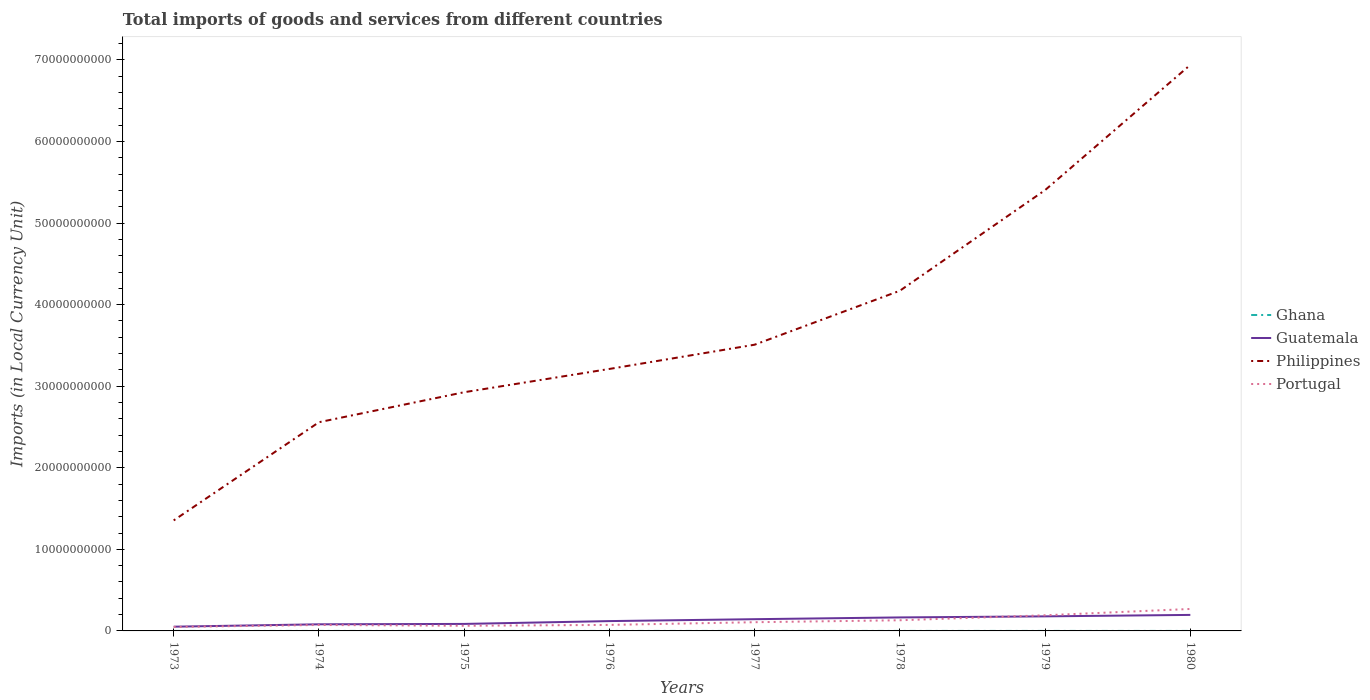Across all years, what is the maximum Amount of goods and services imports in Portugal?
Provide a short and direct response. 4.85e+08. What is the total Amount of goods and services imports in Portugal in the graph?
Offer a terse response. -3.30e+08. What is the difference between the highest and the second highest Amount of goods and services imports in Guatemala?
Ensure brevity in your answer.  1.44e+09. Are the values on the major ticks of Y-axis written in scientific E-notation?
Offer a terse response. No. Does the graph contain grids?
Make the answer very short. No. How many legend labels are there?
Ensure brevity in your answer.  4. How are the legend labels stacked?
Make the answer very short. Vertical. What is the title of the graph?
Provide a short and direct response. Total imports of goods and services from different countries. What is the label or title of the Y-axis?
Your answer should be very brief. Imports (in Local Currency Unit). What is the Imports (in Local Currency Unit) in Ghana in 1973?
Offer a terse response. 5.74e+04. What is the Imports (in Local Currency Unit) of Guatemala in 1973?
Your response must be concise. 5.19e+08. What is the Imports (in Local Currency Unit) in Philippines in 1973?
Offer a very short reply. 1.35e+1. What is the Imports (in Local Currency Unit) in Portugal in 1973?
Ensure brevity in your answer.  4.85e+08. What is the Imports (in Local Currency Unit) of Ghana in 1974?
Keep it short and to the point. 1.02e+05. What is the Imports (in Local Currency Unit) in Guatemala in 1974?
Provide a succinct answer. 8.11e+08. What is the Imports (in Local Currency Unit) of Philippines in 1974?
Keep it short and to the point. 2.56e+1. What is the Imports (in Local Currency Unit) of Portugal in 1974?
Offer a very short reply. 7.30e+08. What is the Imports (in Local Currency Unit) in Ghana in 1975?
Provide a succinct answer. 9.74e+04. What is the Imports (in Local Currency Unit) of Guatemala in 1975?
Your answer should be very brief. 8.58e+08. What is the Imports (in Local Currency Unit) in Philippines in 1975?
Your answer should be compact. 2.93e+1. What is the Imports (in Local Currency Unit) in Portugal in 1975?
Give a very brief answer. 6.30e+08. What is the Imports (in Local Currency Unit) in Ghana in 1976?
Provide a succinct answer. 1.05e+05. What is the Imports (in Local Currency Unit) of Guatemala in 1976?
Your answer should be compact. 1.20e+09. What is the Imports (in Local Currency Unit) of Philippines in 1976?
Ensure brevity in your answer.  3.21e+1. What is the Imports (in Local Currency Unit) of Portugal in 1976?
Keep it short and to the point. 7.38e+08. What is the Imports (in Local Currency Unit) in Ghana in 1977?
Your answer should be very brief. 1.29e+05. What is the Imports (in Local Currency Unit) of Guatemala in 1977?
Your answer should be very brief. 1.44e+09. What is the Imports (in Local Currency Unit) of Philippines in 1977?
Your response must be concise. 3.51e+1. What is the Imports (in Local Currency Unit) of Portugal in 1977?
Offer a terse response. 1.07e+09. What is the Imports (in Local Currency Unit) of Ghana in 1978?
Provide a succinct answer. 2.03e+05. What is the Imports (in Local Currency Unit) of Guatemala in 1978?
Ensure brevity in your answer.  1.66e+09. What is the Imports (in Local Currency Unit) of Philippines in 1978?
Your answer should be very brief. 4.17e+1. What is the Imports (in Local Currency Unit) in Portugal in 1978?
Provide a short and direct response. 1.31e+09. What is the Imports (in Local Currency Unit) of Ghana in 1979?
Keep it short and to the point. 3.15e+05. What is the Imports (in Local Currency Unit) in Guatemala in 1979?
Ensure brevity in your answer.  1.78e+09. What is the Imports (in Local Currency Unit) of Philippines in 1979?
Give a very brief answer. 5.40e+1. What is the Imports (in Local Currency Unit) of Portugal in 1979?
Provide a short and direct response. 1.92e+09. What is the Imports (in Local Currency Unit) in Ghana in 1980?
Make the answer very short. 3.92e+05. What is the Imports (in Local Currency Unit) of Guatemala in 1980?
Keep it short and to the point. 1.96e+09. What is the Imports (in Local Currency Unit) in Philippines in 1980?
Your answer should be very brief. 6.94e+1. What is the Imports (in Local Currency Unit) of Portugal in 1980?
Your response must be concise. 2.69e+09. Across all years, what is the maximum Imports (in Local Currency Unit) in Ghana?
Make the answer very short. 3.92e+05. Across all years, what is the maximum Imports (in Local Currency Unit) in Guatemala?
Offer a very short reply. 1.96e+09. Across all years, what is the maximum Imports (in Local Currency Unit) in Philippines?
Keep it short and to the point. 6.94e+1. Across all years, what is the maximum Imports (in Local Currency Unit) in Portugal?
Your answer should be compact. 2.69e+09. Across all years, what is the minimum Imports (in Local Currency Unit) in Ghana?
Offer a terse response. 5.74e+04. Across all years, what is the minimum Imports (in Local Currency Unit) of Guatemala?
Your answer should be compact. 5.19e+08. Across all years, what is the minimum Imports (in Local Currency Unit) of Philippines?
Provide a succinct answer. 1.35e+1. Across all years, what is the minimum Imports (in Local Currency Unit) of Portugal?
Provide a succinct answer. 4.85e+08. What is the total Imports (in Local Currency Unit) of Ghana in the graph?
Provide a short and direct response. 1.40e+06. What is the total Imports (in Local Currency Unit) in Guatemala in the graph?
Your answer should be compact. 1.02e+1. What is the total Imports (in Local Currency Unit) of Philippines in the graph?
Your answer should be very brief. 3.01e+11. What is the total Imports (in Local Currency Unit) in Portugal in the graph?
Your answer should be compact. 9.57e+09. What is the difference between the Imports (in Local Currency Unit) of Ghana in 1973 and that in 1974?
Your answer should be very brief. -4.42e+04. What is the difference between the Imports (in Local Currency Unit) in Guatemala in 1973 and that in 1974?
Your answer should be very brief. -2.92e+08. What is the difference between the Imports (in Local Currency Unit) of Philippines in 1973 and that in 1974?
Provide a succinct answer. -1.20e+1. What is the difference between the Imports (in Local Currency Unit) of Portugal in 1973 and that in 1974?
Offer a terse response. -2.44e+08. What is the difference between the Imports (in Local Currency Unit) in Guatemala in 1973 and that in 1975?
Provide a short and direct response. -3.39e+08. What is the difference between the Imports (in Local Currency Unit) of Philippines in 1973 and that in 1975?
Provide a short and direct response. -1.57e+1. What is the difference between the Imports (in Local Currency Unit) in Portugal in 1973 and that in 1975?
Give a very brief answer. -1.45e+08. What is the difference between the Imports (in Local Currency Unit) of Ghana in 1973 and that in 1976?
Your response must be concise. -4.73e+04. What is the difference between the Imports (in Local Currency Unit) of Guatemala in 1973 and that in 1976?
Provide a succinct answer. -6.85e+08. What is the difference between the Imports (in Local Currency Unit) of Philippines in 1973 and that in 1976?
Your answer should be compact. -1.86e+1. What is the difference between the Imports (in Local Currency Unit) in Portugal in 1973 and that in 1976?
Make the answer very short. -2.52e+08. What is the difference between the Imports (in Local Currency Unit) in Ghana in 1973 and that in 1977?
Offer a terse response. -7.15e+04. What is the difference between the Imports (in Local Currency Unit) of Guatemala in 1973 and that in 1977?
Make the answer very short. -9.20e+08. What is the difference between the Imports (in Local Currency Unit) of Philippines in 1973 and that in 1977?
Your response must be concise. -2.15e+1. What is the difference between the Imports (in Local Currency Unit) of Portugal in 1973 and that in 1977?
Keep it short and to the point. -5.83e+08. What is the difference between the Imports (in Local Currency Unit) of Ghana in 1973 and that in 1978?
Give a very brief answer. -1.46e+05. What is the difference between the Imports (in Local Currency Unit) of Guatemala in 1973 and that in 1978?
Give a very brief answer. -1.14e+09. What is the difference between the Imports (in Local Currency Unit) in Philippines in 1973 and that in 1978?
Provide a short and direct response. -2.82e+1. What is the difference between the Imports (in Local Currency Unit) in Portugal in 1973 and that in 1978?
Provide a short and direct response. -8.21e+08. What is the difference between the Imports (in Local Currency Unit) in Ghana in 1973 and that in 1979?
Your answer should be very brief. -2.58e+05. What is the difference between the Imports (in Local Currency Unit) of Guatemala in 1973 and that in 1979?
Make the answer very short. -1.27e+09. What is the difference between the Imports (in Local Currency Unit) of Philippines in 1973 and that in 1979?
Keep it short and to the point. -4.05e+1. What is the difference between the Imports (in Local Currency Unit) of Portugal in 1973 and that in 1979?
Give a very brief answer. -1.43e+09. What is the difference between the Imports (in Local Currency Unit) in Ghana in 1973 and that in 1980?
Provide a short and direct response. -3.35e+05. What is the difference between the Imports (in Local Currency Unit) in Guatemala in 1973 and that in 1980?
Your answer should be compact. -1.44e+09. What is the difference between the Imports (in Local Currency Unit) in Philippines in 1973 and that in 1980?
Your answer should be very brief. -5.58e+1. What is the difference between the Imports (in Local Currency Unit) in Portugal in 1973 and that in 1980?
Ensure brevity in your answer.  -2.21e+09. What is the difference between the Imports (in Local Currency Unit) of Ghana in 1974 and that in 1975?
Offer a very short reply. 4200. What is the difference between the Imports (in Local Currency Unit) of Guatemala in 1974 and that in 1975?
Provide a short and direct response. -4.66e+07. What is the difference between the Imports (in Local Currency Unit) in Philippines in 1974 and that in 1975?
Offer a terse response. -3.68e+09. What is the difference between the Imports (in Local Currency Unit) in Portugal in 1974 and that in 1975?
Make the answer very short. 9.95e+07. What is the difference between the Imports (in Local Currency Unit) of Ghana in 1974 and that in 1976?
Give a very brief answer. -3100. What is the difference between the Imports (in Local Currency Unit) of Guatemala in 1974 and that in 1976?
Ensure brevity in your answer.  -3.93e+08. What is the difference between the Imports (in Local Currency Unit) of Philippines in 1974 and that in 1976?
Keep it short and to the point. -6.53e+09. What is the difference between the Imports (in Local Currency Unit) of Portugal in 1974 and that in 1976?
Give a very brief answer. -7.79e+06. What is the difference between the Imports (in Local Currency Unit) in Ghana in 1974 and that in 1977?
Keep it short and to the point. -2.73e+04. What is the difference between the Imports (in Local Currency Unit) in Guatemala in 1974 and that in 1977?
Provide a short and direct response. -6.28e+08. What is the difference between the Imports (in Local Currency Unit) in Philippines in 1974 and that in 1977?
Give a very brief answer. -9.50e+09. What is the difference between the Imports (in Local Currency Unit) of Portugal in 1974 and that in 1977?
Your response must be concise. -3.38e+08. What is the difference between the Imports (in Local Currency Unit) of Ghana in 1974 and that in 1978?
Keep it short and to the point. -1.02e+05. What is the difference between the Imports (in Local Currency Unit) of Guatemala in 1974 and that in 1978?
Keep it short and to the point. -8.44e+08. What is the difference between the Imports (in Local Currency Unit) in Philippines in 1974 and that in 1978?
Give a very brief answer. -1.61e+1. What is the difference between the Imports (in Local Currency Unit) in Portugal in 1974 and that in 1978?
Provide a succinct answer. -5.76e+08. What is the difference between the Imports (in Local Currency Unit) in Ghana in 1974 and that in 1979?
Give a very brief answer. -2.13e+05. What is the difference between the Imports (in Local Currency Unit) of Guatemala in 1974 and that in 1979?
Ensure brevity in your answer.  -9.73e+08. What is the difference between the Imports (in Local Currency Unit) of Philippines in 1974 and that in 1979?
Ensure brevity in your answer.  -2.85e+1. What is the difference between the Imports (in Local Currency Unit) of Portugal in 1974 and that in 1979?
Ensure brevity in your answer.  -1.19e+09. What is the difference between the Imports (in Local Currency Unit) in Ghana in 1974 and that in 1980?
Offer a terse response. -2.91e+05. What is the difference between the Imports (in Local Currency Unit) in Guatemala in 1974 and that in 1980?
Keep it short and to the point. -1.15e+09. What is the difference between the Imports (in Local Currency Unit) in Philippines in 1974 and that in 1980?
Provide a succinct answer. -4.38e+1. What is the difference between the Imports (in Local Currency Unit) of Portugal in 1974 and that in 1980?
Offer a very short reply. -1.96e+09. What is the difference between the Imports (in Local Currency Unit) in Ghana in 1975 and that in 1976?
Your answer should be very brief. -7300. What is the difference between the Imports (in Local Currency Unit) of Guatemala in 1975 and that in 1976?
Provide a succinct answer. -3.46e+08. What is the difference between the Imports (in Local Currency Unit) of Philippines in 1975 and that in 1976?
Offer a very short reply. -2.85e+09. What is the difference between the Imports (in Local Currency Unit) of Portugal in 1975 and that in 1976?
Ensure brevity in your answer.  -1.07e+08. What is the difference between the Imports (in Local Currency Unit) of Ghana in 1975 and that in 1977?
Your response must be concise. -3.15e+04. What is the difference between the Imports (in Local Currency Unit) in Guatemala in 1975 and that in 1977?
Your response must be concise. -5.81e+08. What is the difference between the Imports (in Local Currency Unit) in Philippines in 1975 and that in 1977?
Your answer should be compact. -5.83e+09. What is the difference between the Imports (in Local Currency Unit) of Portugal in 1975 and that in 1977?
Keep it short and to the point. -4.38e+08. What is the difference between the Imports (in Local Currency Unit) of Ghana in 1975 and that in 1978?
Offer a terse response. -1.06e+05. What is the difference between the Imports (in Local Currency Unit) in Guatemala in 1975 and that in 1978?
Ensure brevity in your answer.  -7.97e+08. What is the difference between the Imports (in Local Currency Unit) in Philippines in 1975 and that in 1978?
Offer a terse response. -1.24e+1. What is the difference between the Imports (in Local Currency Unit) in Portugal in 1975 and that in 1978?
Ensure brevity in your answer.  -6.76e+08. What is the difference between the Imports (in Local Currency Unit) in Ghana in 1975 and that in 1979?
Provide a succinct answer. -2.18e+05. What is the difference between the Imports (in Local Currency Unit) in Guatemala in 1975 and that in 1979?
Offer a very short reply. -9.26e+08. What is the difference between the Imports (in Local Currency Unit) of Philippines in 1975 and that in 1979?
Your response must be concise. -2.48e+1. What is the difference between the Imports (in Local Currency Unit) of Portugal in 1975 and that in 1979?
Make the answer very short. -1.29e+09. What is the difference between the Imports (in Local Currency Unit) of Ghana in 1975 and that in 1980?
Your answer should be very brief. -2.95e+05. What is the difference between the Imports (in Local Currency Unit) of Guatemala in 1975 and that in 1980?
Provide a succinct answer. -1.11e+09. What is the difference between the Imports (in Local Currency Unit) of Philippines in 1975 and that in 1980?
Provide a short and direct response. -4.01e+1. What is the difference between the Imports (in Local Currency Unit) in Portugal in 1975 and that in 1980?
Your answer should be compact. -2.06e+09. What is the difference between the Imports (in Local Currency Unit) of Ghana in 1976 and that in 1977?
Provide a short and direct response. -2.42e+04. What is the difference between the Imports (in Local Currency Unit) of Guatemala in 1976 and that in 1977?
Offer a very short reply. -2.35e+08. What is the difference between the Imports (in Local Currency Unit) of Philippines in 1976 and that in 1977?
Give a very brief answer. -2.97e+09. What is the difference between the Imports (in Local Currency Unit) in Portugal in 1976 and that in 1977?
Your response must be concise. -3.30e+08. What is the difference between the Imports (in Local Currency Unit) in Ghana in 1976 and that in 1978?
Your answer should be very brief. -9.86e+04. What is the difference between the Imports (in Local Currency Unit) in Guatemala in 1976 and that in 1978?
Make the answer very short. -4.51e+08. What is the difference between the Imports (in Local Currency Unit) of Philippines in 1976 and that in 1978?
Give a very brief answer. -9.59e+09. What is the difference between the Imports (in Local Currency Unit) in Portugal in 1976 and that in 1978?
Your response must be concise. -5.69e+08. What is the difference between the Imports (in Local Currency Unit) in Ghana in 1976 and that in 1979?
Offer a terse response. -2.10e+05. What is the difference between the Imports (in Local Currency Unit) in Guatemala in 1976 and that in 1979?
Keep it short and to the point. -5.80e+08. What is the difference between the Imports (in Local Currency Unit) of Philippines in 1976 and that in 1979?
Your answer should be compact. -2.19e+1. What is the difference between the Imports (in Local Currency Unit) of Portugal in 1976 and that in 1979?
Ensure brevity in your answer.  -1.18e+09. What is the difference between the Imports (in Local Currency Unit) of Ghana in 1976 and that in 1980?
Offer a terse response. -2.88e+05. What is the difference between the Imports (in Local Currency Unit) of Guatemala in 1976 and that in 1980?
Provide a succinct answer. -7.59e+08. What is the difference between the Imports (in Local Currency Unit) of Philippines in 1976 and that in 1980?
Provide a short and direct response. -3.73e+1. What is the difference between the Imports (in Local Currency Unit) in Portugal in 1976 and that in 1980?
Your answer should be compact. -1.96e+09. What is the difference between the Imports (in Local Currency Unit) in Ghana in 1977 and that in 1978?
Provide a short and direct response. -7.44e+04. What is the difference between the Imports (in Local Currency Unit) in Guatemala in 1977 and that in 1978?
Your response must be concise. -2.16e+08. What is the difference between the Imports (in Local Currency Unit) in Philippines in 1977 and that in 1978?
Make the answer very short. -6.62e+09. What is the difference between the Imports (in Local Currency Unit) of Portugal in 1977 and that in 1978?
Your response must be concise. -2.38e+08. What is the difference between the Imports (in Local Currency Unit) in Ghana in 1977 and that in 1979?
Give a very brief answer. -1.86e+05. What is the difference between the Imports (in Local Currency Unit) of Guatemala in 1977 and that in 1979?
Ensure brevity in your answer.  -3.45e+08. What is the difference between the Imports (in Local Currency Unit) of Philippines in 1977 and that in 1979?
Your answer should be compact. -1.90e+1. What is the difference between the Imports (in Local Currency Unit) of Portugal in 1977 and that in 1979?
Provide a succinct answer. -8.51e+08. What is the difference between the Imports (in Local Currency Unit) in Ghana in 1977 and that in 1980?
Make the answer very short. -2.63e+05. What is the difference between the Imports (in Local Currency Unit) of Guatemala in 1977 and that in 1980?
Keep it short and to the point. -5.24e+08. What is the difference between the Imports (in Local Currency Unit) in Philippines in 1977 and that in 1980?
Your answer should be compact. -3.43e+1. What is the difference between the Imports (in Local Currency Unit) of Portugal in 1977 and that in 1980?
Your response must be concise. -1.62e+09. What is the difference between the Imports (in Local Currency Unit) of Ghana in 1978 and that in 1979?
Keep it short and to the point. -1.12e+05. What is the difference between the Imports (in Local Currency Unit) of Guatemala in 1978 and that in 1979?
Ensure brevity in your answer.  -1.29e+08. What is the difference between the Imports (in Local Currency Unit) in Philippines in 1978 and that in 1979?
Provide a short and direct response. -1.23e+1. What is the difference between the Imports (in Local Currency Unit) in Portugal in 1978 and that in 1979?
Provide a succinct answer. -6.13e+08. What is the difference between the Imports (in Local Currency Unit) of Ghana in 1978 and that in 1980?
Offer a terse response. -1.89e+05. What is the difference between the Imports (in Local Currency Unit) in Guatemala in 1978 and that in 1980?
Make the answer very short. -3.08e+08. What is the difference between the Imports (in Local Currency Unit) in Philippines in 1978 and that in 1980?
Your answer should be very brief. -2.77e+1. What is the difference between the Imports (in Local Currency Unit) in Portugal in 1978 and that in 1980?
Make the answer very short. -1.39e+09. What is the difference between the Imports (in Local Currency Unit) in Ghana in 1979 and that in 1980?
Keep it short and to the point. -7.73e+04. What is the difference between the Imports (in Local Currency Unit) in Guatemala in 1979 and that in 1980?
Keep it short and to the point. -1.79e+08. What is the difference between the Imports (in Local Currency Unit) in Philippines in 1979 and that in 1980?
Keep it short and to the point. -1.54e+1. What is the difference between the Imports (in Local Currency Unit) in Portugal in 1979 and that in 1980?
Offer a terse response. -7.74e+08. What is the difference between the Imports (in Local Currency Unit) of Ghana in 1973 and the Imports (in Local Currency Unit) of Guatemala in 1974?
Your answer should be compact. -8.11e+08. What is the difference between the Imports (in Local Currency Unit) of Ghana in 1973 and the Imports (in Local Currency Unit) of Philippines in 1974?
Provide a short and direct response. -2.56e+1. What is the difference between the Imports (in Local Currency Unit) of Ghana in 1973 and the Imports (in Local Currency Unit) of Portugal in 1974?
Offer a very short reply. -7.30e+08. What is the difference between the Imports (in Local Currency Unit) of Guatemala in 1973 and the Imports (in Local Currency Unit) of Philippines in 1974?
Give a very brief answer. -2.51e+1. What is the difference between the Imports (in Local Currency Unit) in Guatemala in 1973 and the Imports (in Local Currency Unit) in Portugal in 1974?
Your answer should be compact. -2.11e+08. What is the difference between the Imports (in Local Currency Unit) of Philippines in 1973 and the Imports (in Local Currency Unit) of Portugal in 1974?
Keep it short and to the point. 1.28e+1. What is the difference between the Imports (in Local Currency Unit) in Ghana in 1973 and the Imports (in Local Currency Unit) in Guatemala in 1975?
Ensure brevity in your answer.  -8.58e+08. What is the difference between the Imports (in Local Currency Unit) of Ghana in 1973 and the Imports (in Local Currency Unit) of Philippines in 1975?
Offer a terse response. -2.93e+1. What is the difference between the Imports (in Local Currency Unit) in Ghana in 1973 and the Imports (in Local Currency Unit) in Portugal in 1975?
Offer a terse response. -6.30e+08. What is the difference between the Imports (in Local Currency Unit) of Guatemala in 1973 and the Imports (in Local Currency Unit) of Philippines in 1975?
Make the answer very short. -2.87e+1. What is the difference between the Imports (in Local Currency Unit) of Guatemala in 1973 and the Imports (in Local Currency Unit) of Portugal in 1975?
Give a very brief answer. -1.11e+08. What is the difference between the Imports (in Local Currency Unit) of Philippines in 1973 and the Imports (in Local Currency Unit) of Portugal in 1975?
Offer a very short reply. 1.29e+1. What is the difference between the Imports (in Local Currency Unit) of Ghana in 1973 and the Imports (in Local Currency Unit) of Guatemala in 1976?
Make the answer very short. -1.20e+09. What is the difference between the Imports (in Local Currency Unit) of Ghana in 1973 and the Imports (in Local Currency Unit) of Philippines in 1976?
Offer a terse response. -3.21e+1. What is the difference between the Imports (in Local Currency Unit) of Ghana in 1973 and the Imports (in Local Currency Unit) of Portugal in 1976?
Offer a very short reply. -7.38e+08. What is the difference between the Imports (in Local Currency Unit) of Guatemala in 1973 and the Imports (in Local Currency Unit) of Philippines in 1976?
Offer a very short reply. -3.16e+1. What is the difference between the Imports (in Local Currency Unit) of Guatemala in 1973 and the Imports (in Local Currency Unit) of Portugal in 1976?
Offer a very short reply. -2.18e+08. What is the difference between the Imports (in Local Currency Unit) of Philippines in 1973 and the Imports (in Local Currency Unit) of Portugal in 1976?
Provide a succinct answer. 1.28e+1. What is the difference between the Imports (in Local Currency Unit) of Ghana in 1973 and the Imports (in Local Currency Unit) of Guatemala in 1977?
Your response must be concise. -1.44e+09. What is the difference between the Imports (in Local Currency Unit) in Ghana in 1973 and the Imports (in Local Currency Unit) in Philippines in 1977?
Your answer should be compact. -3.51e+1. What is the difference between the Imports (in Local Currency Unit) of Ghana in 1973 and the Imports (in Local Currency Unit) of Portugal in 1977?
Make the answer very short. -1.07e+09. What is the difference between the Imports (in Local Currency Unit) in Guatemala in 1973 and the Imports (in Local Currency Unit) in Philippines in 1977?
Your response must be concise. -3.46e+1. What is the difference between the Imports (in Local Currency Unit) in Guatemala in 1973 and the Imports (in Local Currency Unit) in Portugal in 1977?
Make the answer very short. -5.49e+08. What is the difference between the Imports (in Local Currency Unit) of Philippines in 1973 and the Imports (in Local Currency Unit) of Portugal in 1977?
Offer a terse response. 1.25e+1. What is the difference between the Imports (in Local Currency Unit) in Ghana in 1973 and the Imports (in Local Currency Unit) in Guatemala in 1978?
Your answer should be compact. -1.65e+09. What is the difference between the Imports (in Local Currency Unit) of Ghana in 1973 and the Imports (in Local Currency Unit) of Philippines in 1978?
Your answer should be compact. -4.17e+1. What is the difference between the Imports (in Local Currency Unit) of Ghana in 1973 and the Imports (in Local Currency Unit) of Portugal in 1978?
Your answer should be very brief. -1.31e+09. What is the difference between the Imports (in Local Currency Unit) in Guatemala in 1973 and the Imports (in Local Currency Unit) in Philippines in 1978?
Provide a succinct answer. -4.12e+1. What is the difference between the Imports (in Local Currency Unit) in Guatemala in 1973 and the Imports (in Local Currency Unit) in Portugal in 1978?
Your answer should be compact. -7.87e+08. What is the difference between the Imports (in Local Currency Unit) of Philippines in 1973 and the Imports (in Local Currency Unit) of Portugal in 1978?
Make the answer very short. 1.22e+1. What is the difference between the Imports (in Local Currency Unit) in Ghana in 1973 and the Imports (in Local Currency Unit) in Guatemala in 1979?
Give a very brief answer. -1.78e+09. What is the difference between the Imports (in Local Currency Unit) of Ghana in 1973 and the Imports (in Local Currency Unit) of Philippines in 1979?
Your response must be concise. -5.40e+1. What is the difference between the Imports (in Local Currency Unit) of Ghana in 1973 and the Imports (in Local Currency Unit) of Portugal in 1979?
Ensure brevity in your answer.  -1.92e+09. What is the difference between the Imports (in Local Currency Unit) of Guatemala in 1973 and the Imports (in Local Currency Unit) of Philippines in 1979?
Your answer should be very brief. -5.35e+1. What is the difference between the Imports (in Local Currency Unit) in Guatemala in 1973 and the Imports (in Local Currency Unit) in Portugal in 1979?
Provide a succinct answer. -1.40e+09. What is the difference between the Imports (in Local Currency Unit) of Philippines in 1973 and the Imports (in Local Currency Unit) of Portugal in 1979?
Your response must be concise. 1.16e+1. What is the difference between the Imports (in Local Currency Unit) of Ghana in 1973 and the Imports (in Local Currency Unit) of Guatemala in 1980?
Offer a terse response. -1.96e+09. What is the difference between the Imports (in Local Currency Unit) in Ghana in 1973 and the Imports (in Local Currency Unit) in Philippines in 1980?
Keep it short and to the point. -6.94e+1. What is the difference between the Imports (in Local Currency Unit) of Ghana in 1973 and the Imports (in Local Currency Unit) of Portugal in 1980?
Your answer should be very brief. -2.69e+09. What is the difference between the Imports (in Local Currency Unit) of Guatemala in 1973 and the Imports (in Local Currency Unit) of Philippines in 1980?
Ensure brevity in your answer.  -6.89e+1. What is the difference between the Imports (in Local Currency Unit) of Guatemala in 1973 and the Imports (in Local Currency Unit) of Portugal in 1980?
Your response must be concise. -2.17e+09. What is the difference between the Imports (in Local Currency Unit) of Philippines in 1973 and the Imports (in Local Currency Unit) of Portugal in 1980?
Make the answer very short. 1.09e+1. What is the difference between the Imports (in Local Currency Unit) of Ghana in 1974 and the Imports (in Local Currency Unit) of Guatemala in 1975?
Offer a very short reply. -8.58e+08. What is the difference between the Imports (in Local Currency Unit) in Ghana in 1974 and the Imports (in Local Currency Unit) in Philippines in 1975?
Offer a terse response. -2.93e+1. What is the difference between the Imports (in Local Currency Unit) in Ghana in 1974 and the Imports (in Local Currency Unit) in Portugal in 1975?
Make the answer very short. -6.30e+08. What is the difference between the Imports (in Local Currency Unit) of Guatemala in 1974 and the Imports (in Local Currency Unit) of Philippines in 1975?
Offer a very short reply. -2.85e+1. What is the difference between the Imports (in Local Currency Unit) in Guatemala in 1974 and the Imports (in Local Currency Unit) in Portugal in 1975?
Keep it short and to the point. 1.81e+08. What is the difference between the Imports (in Local Currency Unit) in Philippines in 1974 and the Imports (in Local Currency Unit) in Portugal in 1975?
Your response must be concise. 2.50e+1. What is the difference between the Imports (in Local Currency Unit) of Ghana in 1974 and the Imports (in Local Currency Unit) of Guatemala in 1976?
Offer a very short reply. -1.20e+09. What is the difference between the Imports (in Local Currency Unit) of Ghana in 1974 and the Imports (in Local Currency Unit) of Philippines in 1976?
Your answer should be compact. -3.21e+1. What is the difference between the Imports (in Local Currency Unit) in Ghana in 1974 and the Imports (in Local Currency Unit) in Portugal in 1976?
Provide a short and direct response. -7.37e+08. What is the difference between the Imports (in Local Currency Unit) in Guatemala in 1974 and the Imports (in Local Currency Unit) in Philippines in 1976?
Provide a succinct answer. -3.13e+1. What is the difference between the Imports (in Local Currency Unit) in Guatemala in 1974 and the Imports (in Local Currency Unit) in Portugal in 1976?
Offer a terse response. 7.38e+07. What is the difference between the Imports (in Local Currency Unit) in Philippines in 1974 and the Imports (in Local Currency Unit) in Portugal in 1976?
Provide a short and direct response. 2.48e+1. What is the difference between the Imports (in Local Currency Unit) in Ghana in 1974 and the Imports (in Local Currency Unit) in Guatemala in 1977?
Your answer should be compact. -1.44e+09. What is the difference between the Imports (in Local Currency Unit) in Ghana in 1974 and the Imports (in Local Currency Unit) in Philippines in 1977?
Your answer should be compact. -3.51e+1. What is the difference between the Imports (in Local Currency Unit) in Ghana in 1974 and the Imports (in Local Currency Unit) in Portugal in 1977?
Provide a succinct answer. -1.07e+09. What is the difference between the Imports (in Local Currency Unit) in Guatemala in 1974 and the Imports (in Local Currency Unit) in Philippines in 1977?
Your answer should be compact. -3.43e+1. What is the difference between the Imports (in Local Currency Unit) of Guatemala in 1974 and the Imports (in Local Currency Unit) of Portugal in 1977?
Your answer should be compact. -2.57e+08. What is the difference between the Imports (in Local Currency Unit) of Philippines in 1974 and the Imports (in Local Currency Unit) of Portugal in 1977?
Provide a short and direct response. 2.45e+1. What is the difference between the Imports (in Local Currency Unit) of Ghana in 1974 and the Imports (in Local Currency Unit) of Guatemala in 1978?
Keep it short and to the point. -1.65e+09. What is the difference between the Imports (in Local Currency Unit) in Ghana in 1974 and the Imports (in Local Currency Unit) in Philippines in 1978?
Offer a very short reply. -4.17e+1. What is the difference between the Imports (in Local Currency Unit) of Ghana in 1974 and the Imports (in Local Currency Unit) of Portugal in 1978?
Your answer should be very brief. -1.31e+09. What is the difference between the Imports (in Local Currency Unit) in Guatemala in 1974 and the Imports (in Local Currency Unit) in Philippines in 1978?
Provide a short and direct response. -4.09e+1. What is the difference between the Imports (in Local Currency Unit) in Guatemala in 1974 and the Imports (in Local Currency Unit) in Portugal in 1978?
Ensure brevity in your answer.  -4.95e+08. What is the difference between the Imports (in Local Currency Unit) in Philippines in 1974 and the Imports (in Local Currency Unit) in Portugal in 1978?
Your response must be concise. 2.43e+1. What is the difference between the Imports (in Local Currency Unit) in Ghana in 1974 and the Imports (in Local Currency Unit) in Guatemala in 1979?
Your answer should be very brief. -1.78e+09. What is the difference between the Imports (in Local Currency Unit) in Ghana in 1974 and the Imports (in Local Currency Unit) in Philippines in 1979?
Your answer should be compact. -5.40e+1. What is the difference between the Imports (in Local Currency Unit) in Ghana in 1974 and the Imports (in Local Currency Unit) in Portugal in 1979?
Offer a terse response. -1.92e+09. What is the difference between the Imports (in Local Currency Unit) in Guatemala in 1974 and the Imports (in Local Currency Unit) in Philippines in 1979?
Make the answer very short. -5.32e+1. What is the difference between the Imports (in Local Currency Unit) in Guatemala in 1974 and the Imports (in Local Currency Unit) in Portugal in 1979?
Make the answer very short. -1.11e+09. What is the difference between the Imports (in Local Currency Unit) of Philippines in 1974 and the Imports (in Local Currency Unit) of Portugal in 1979?
Keep it short and to the point. 2.37e+1. What is the difference between the Imports (in Local Currency Unit) in Ghana in 1974 and the Imports (in Local Currency Unit) in Guatemala in 1980?
Your response must be concise. -1.96e+09. What is the difference between the Imports (in Local Currency Unit) in Ghana in 1974 and the Imports (in Local Currency Unit) in Philippines in 1980?
Make the answer very short. -6.94e+1. What is the difference between the Imports (in Local Currency Unit) in Ghana in 1974 and the Imports (in Local Currency Unit) in Portugal in 1980?
Your answer should be compact. -2.69e+09. What is the difference between the Imports (in Local Currency Unit) of Guatemala in 1974 and the Imports (in Local Currency Unit) of Philippines in 1980?
Keep it short and to the point. -6.86e+1. What is the difference between the Imports (in Local Currency Unit) of Guatemala in 1974 and the Imports (in Local Currency Unit) of Portugal in 1980?
Provide a short and direct response. -1.88e+09. What is the difference between the Imports (in Local Currency Unit) in Philippines in 1974 and the Imports (in Local Currency Unit) in Portugal in 1980?
Keep it short and to the point. 2.29e+1. What is the difference between the Imports (in Local Currency Unit) of Ghana in 1975 and the Imports (in Local Currency Unit) of Guatemala in 1976?
Your answer should be very brief. -1.20e+09. What is the difference between the Imports (in Local Currency Unit) in Ghana in 1975 and the Imports (in Local Currency Unit) in Philippines in 1976?
Provide a succinct answer. -3.21e+1. What is the difference between the Imports (in Local Currency Unit) of Ghana in 1975 and the Imports (in Local Currency Unit) of Portugal in 1976?
Your response must be concise. -7.37e+08. What is the difference between the Imports (in Local Currency Unit) in Guatemala in 1975 and the Imports (in Local Currency Unit) in Philippines in 1976?
Your response must be concise. -3.13e+1. What is the difference between the Imports (in Local Currency Unit) of Guatemala in 1975 and the Imports (in Local Currency Unit) of Portugal in 1976?
Offer a very short reply. 1.20e+08. What is the difference between the Imports (in Local Currency Unit) of Philippines in 1975 and the Imports (in Local Currency Unit) of Portugal in 1976?
Your answer should be very brief. 2.85e+1. What is the difference between the Imports (in Local Currency Unit) of Ghana in 1975 and the Imports (in Local Currency Unit) of Guatemala in 1977?
Keep it short and to the point. -1.44e+09. What is the difference between the Imports (in Local Currency Unit) in Ghana in 1975 and the Imports (in Local Currency Unit) in Philippines in 1977?
Offer a very short reply. -3.51e+1. What is the difference between the Imports (in Local Currency Unit) in Ghana in 1975 and the Imports (in Local Currency Unit) in Portugal in 1977?
Your answer should be very brief. -1.07e+09. What is the difference between the Imports (in Local Currency Unit) of Guatemala in 1975 and the Imports (in Local Currency Unit) of Philippines in 1977?
Provide a short and direct response. -3.42e+1. What is the difference between the Imports (in Local Currency Unit) of Guatemala in 1975 and the Imports (in Local Currency Unit) of Portugal in 1977?
Make the answer very short. -2.10e+08. What is the difference between the Imports (in Local Currency Unit) of Philippines in 1975 and the Imports (in Local Currency Unit) of Portugal in 1977?
Keep it short and to the point. 2.82e+1. What is the difference between the Imports (in Local Currency Unit) in Ghana in 1975 and the Imports (in Local Currency Unit) in Guatemala in 1978?
Ensure brevity in your answer.  -1.65e+09. What is the difference between the Imports (in Local Currency Unit) of Ghana in 1975 and the Imports (in Local Currency Unit) of Philippines in 1978?
Provide a succinct answer. -4.17e+1. What is the difference between the Imports (in Local Currency Unit) in Ghana in 1975 and the Imports (in Local Currency Unit) in Portugal in 1978?
Offer a terse response. -1.31e+09. What is the difference between the Imports (in Local Currency Unit) in Guatemala in 1975 and the Imports (in Local Currency Unit) in Philippines in 1978?
Your answer should be compact. -4.08e+1. What is the difference between the Imports (in Local Currency Unit) in Guatemala in 1975 and the Imports (in Local Currency Unit) in Portugal in 1978?
Give a very brief answer. -4.48e+08. What is the difference between the Imports (in Local Currency Unit) in Philippines in 1975 and the Imports (in Local Currency Unit) in Portugal in 1978?
Ensure brevity in your answer.  2.80e+1. What is the difference between the Imports (in Local Currency Unit) in Ghana in 1975 and the Imports (in Local Currency Unit) in Guatemala in 1979?
Provide a short and direct response. -1.78e+09. What is the difference between the Imports (in Local Currency Unit) in Ghana in 1975 and the Imports (in Local Currency Unit) in Philippines in 1979?
Offer a terse response. -5.40e+1. What is the difference between the Imports (in Local Currency Unit) in Ghana in 1975 and the Imports (in Local Currency Unit) in Portugal in 1979?
Provide a succinct answer. -1.92e+09. What is the difference between the Imports (in Local Currency Unit) of Guatemala in 1975 and the Imports (in Local Currency Unit) of Philippines in 1979?
Keep it short and to the point. -5.32e+1. What is the difference between the Imports (in Local Currency Unit) of Guatemala in 1975 and the Imports (in Local Currency Unit) of Portugal in 1979?
Offer a terse response. -1.06e+09. What is the difference between the Imports (in Local Currency Unit) of Philippines in 1975 and the Imports (in Local Currency Unit) of Portugal in 1979?
Give a very brief answer. 2.73e+1. What is the difference between the Imports (in Local Currency Unit) of Ghana in 1975 and the Imports (in Local Currency Unit) of Guatemala in 1980?
Offer a terse response. -1.96e+09. What is the difference between the Imports (in Local Currency Unit) of Ghana in 1975 and the Imports (in Local Currency Unit) of Philippines in 1980?
Your answer should be very brief. -6.94e+1. What is the difference between the Imports (in Local Currency Unit) in Ghana in 1975 and the Imports (in Local Currency Unit) in Portugal in 1980?
Offer a very short reply. -2.69e+09. What is the difference between the Imports (in Local Currency Unit) in Guatemala in 1975 and the Imports (in Local Currency Unit) in Philippines in 1980?
Keep it short and to the point. -6.85e+1. What is the difference between the Imports (in Local Currency Unit) of Guatemala in 1975 and the Imports (in Local Currency Unit) of Portugal in 1980?
Make the answer very short. -1.83e+09. What is the difference between the Imports (in Local Currency Unit) of Philippines in 1975 and the Imports (in Local Currency Unit) of Portugal in 1980?
Your response must be concise. 2.66e+1. What is the difference between the Imports (in Local Currency Unit) in Ghana in 1976 and the Imports (in Local Currency Unit) in Guatemala in 1977?
Offer a terse response. -1.44e+09. What is the difference between the Imports (in Local Currency Unit) in Ghana in 1976 and the Imports (in Local Currency Unit) in Philippines in 1977?
Make the answer very short. -3.51e+1. What is the difference between the Imports (in Local Currency Unit) of Ghana in 1976 and the Imports (in Local Currency Unit) of Portugal in 1977?
Your answer should be very brief. -1.07e+09. What is the difference between the Imports (in Local Currency Unit) of Guatemala in 1976 and the Imports (in Local Currency Unit) of Philippines in 1977?
Give a very brief answer. -3.39e+1. What is the difference between the Imports (in Local Currency Unit) in Guatemala in 1976 and the Imports (in Local Currency Unit) in Portugal in 1977?
Your answer should be compact. 1.36e+08. What is the difference between the Imports (in Local Currency Unit) of Philippines in 1976 and the Imports (in Local Currency Unit) of Portugal in 1977?
Offer a very short reply. 3.11e+1. What is the difference between the Imports (in Local Currency Unit) in Ghana in 1976 and the Imports (in Local Currency Unit) in Guatemala in 1978?
Offer a very short reply. -1.65e+09. What is the difference between the Imports (in Local Currency Unit) of Ghana in 1976 and the Imports (in Local Currency Unit) of Philippines in 1978?
Provide a short and direct response. -4.17e+1. What is the difference between the Imports (in Local Currency Unit) in Ghana in 1976 and the Imports (in Local Currency Unit) in Portugal in 1978?
Offer a terse response. -1.31e+09. What is the difference between the Imports (in Local Currency Unit) of Guatemala in 1976 and the Imports (in Local Currency Unit) of Philippines in 1978?
Ensure brevity in your answer.  -4.05e+1. What is the difference between the Imports (in Local Currency Unit) in Guatemala in 1976 and the Imports (in Local Currency Unit) in Portugal in 1978?
Give a very brief answer. -1.02e+08. What is the difference between the Imports (in Local Currency Unit) of Philippines in 1976 and the Imports (in Local Currency Unit) of Portugal in 1978?
Your answer should be compact. 3.08e+1. What is the difference between the Imports (in Local Currency Unit) of Ghana in 1976 and the Imports (in Local Currency Unit) of Guatemala in 1979?
Your answer should be compact. -1.78e+09. What is the difference between the Imports (in Local Currency Unit) in Ghana in 1976 and the Imports (in Local Currency Unit) in Philippines in 1979?
Provide a succinct answer. -5.40e+1. What is the difference between the Imports (in Local Currency Unit) in Ghana in 1976 and the Imports (in Local Currency Unit) in Portugal in 1979?
Provide a succinct answer. -1.92e+09. What is the difference between the Imports (in Local Currency Unit) in Guatemala in 1976 and the Imports (in Local Currency Unit) in Philippines in 1979?
Your answer should be compact. -5.28e+1. What is the difference between the Imports (in Local Currency Unit) in Guatemala in 1976 and the Imports (in Local Currency Unit) in Portugal in 1979?
Give a very brief answer. -7.15e+08. What is the difference between the Imports (in Local Currency Unit) in Philippines in 1976 and the Imports (in Local Currency Unit) in Portugal in 1979?
Your answer should be compact. 3.02e+1. What is the difference between the Imports (in Local Currency Unit) in Ghana in 1976 and the Imports (in Local Currency Unit) in Guatemala in 1980?
Ensure brevity in your answer.  -1.96e+09. What is the difference between the Imports (in Local Currency Unit) of Ghana in 1976 and the Imports (in Local Currency Unit) of Philippines in 1980?
Provide a short and direct response. -6.94e+1. What is the difference between the Imports (in Local Currency Unit) in Ghana in 1976 and the Imports (in Local Currency Unit) in Portugal in 1980?
Provide a succinct answer. -2.69e+09. What is the difference between the Imports (in Local Currency Unit) in Guatemala in 1976 and the Imports (in Local Currency Unit) in Philippines in 1980?
Keep it short and to the point. -6.82e+1. What is the difference between the Imports (in Local Currency Unit) in Guatemala in 1976 and the Imports (in Local Currency Unit) in Portugal in 1980?
Your answer should be compact. -1.49e+09. What is the difference between the Imports (in Local Currency Unit) in Philippines in 1976 and the Imports (in Local Currency Unit) in Portugal in 1980?
Offer a terse response. 2.94e+1. What is the difference between the Imports (in Local Currency Unit) of Ghana in 1977 and the Imports (in Local Currency Unit) of Guatemala in 1978?
Provide a short and direct response. -1.65e+09. What is the difference between the Imports (in Local Currency Unit) in Ghana in 1977 and the Imports (in Local Currency Unit) in Philippines in 1978?
Your response must be concise. -4.17e+1. What is the difference between the Imports (in Local Currency Unit) of Ghana in 1977 and the Imports (in Local Currency Unit) of Portugal in 1978?
Give a very brief answer. -1.31e+09. What is the difference between the Imports (in Local Currency Unit) of Guatemala in 1977 and the Imports (in Local Currency Unit) of Philippines in 1978?
Offer a very short reply. -4.03e+1. What is the difference between the Imports (in Local Currency Unit) in Guatemala in 1977 and the Imports (in Local Currency Unit) in Portugal in 1978?
Provide a short and direct response. 1.33e+08. What is the difference between the Imports (in Local Currency Unit) in Philippines in 1977 and the Imports (in Local Currency Unit) in Portugal in 1978?
Your response must be concise. 3.38e+1. What is the difference between the Imports (in Local Currency Unit) in Ghana in 1977 and the Imports (in Local Currency Unit) in Guatemala in 1979?
Your answer should be very brief. -1.78e+09. What is the difference between the Imports (in Local Currency Unit) of Ghana in 1977 and the Imports (in Local Currency Unit) of Philippines in 1979?
Give a very brief answer. -5.40e+1. What is the difference between the Imports (in Local Currency Unit) of Ghana in 1977 and the Imports (in Local Currency Unit) of Portugal in 1979?
Your answer should be very brief. -1.92e+09. What is the difference between the Imports (in Local Currency Unit) in Guatemala in 1977 and the Imports (in Local Currency Unit) in Philippines in 1979?
Your answer should be compact. -5.26e+1. What is the difference between the Imports (in Local Currency Unit) in Guatemala in 1977 and the Imports (in Local Currency Unit) in Portugal in 1979?
Make the answer very short. -4.80e+08. What is the difference between the Imports (in Local Currency Unit) of Philippines in 1977 and the Imports (in Local Currency Unit) of Portugal in 1979?
Provide a short and direct response. 3.32e+1. What is the difference between the Imports (in Local Currency Unit) in Ghana in 1977 and the Imports (in Local Currency Unit) in Guatemala in 1980?
Keep it short and to the point. -1.96e+09. What is the difference between the Imports (in Local Currency Unit) of Ghana in 1977 and the Imports (in Local Currency Unit) of Philippines in 1980?
Provide a succinct answer. -6.94e+1. What is the difference between the Imports (in Local Currency Unit) of Ghana in 1977 and the Imports (in Local Currency Unit) of Portugal in 1980?
Your answer should be compact. -2.69e+09. What is the difference between the Imports (in Local Currency Unit) of Guatemala in 1977 and the Imports (in Local Currency Unit) of Philippines in 1980?
Give a very brief answer. -6.80e+1. What is the difference between the Imports (in Local Currency Unit) of Guatemala in 1977 and the Imports (in Local Currency Unit) of Portugal in 1980?
Ensure brevity in your answer.  -1.25e+09. What is the difference between the Imports (in Local Currency Unit) of Philippines in 1977 and the Imports (in Local Currency Unit) of Portugal in 1980?
Offer a very short reply. 3.24e+1. What is the difference between the Imports (in Local Currency Unit) of Ghana in 1978 and the Imports (in Local Currency Unit) of Guatemala in 1979?
Provide a succinct answer. -1.78e+09. What is the difference between the Imports (in Local Currency Unit) in Ghana in 1978 and the Imports (in Local Currency Unit) in Philippines in 1979?
Give a very brief answer. -5.40e+1. What is the difference between the Imports (in Local Currency Unit) in Ghana in 1978 and the Imports (in Local Currency Unit) in Portugal in 1979?
Keep it short and to the point. -1.92e+09. What is the difference between the Imports (in Local Currency Unit) in Guatemala in 1978 and the Imports (in Local Currency Unit) in Philippines in 1979?
Keep it short and to the point. -5.24e+1. What is the difference between the Imports (in Local Currency Unit) of Guatemala in 1978 and the Imports (in Local Currency Unit) of Portugal in 1979?
Give a very brief answer. -2.64e+08. What is the difference between the Imports (in Local Currency Unit) in Philippines in 1978 and the Imports (in Local Currency Unit) in Portugal in 1979?
Your answer should be very brief. 3.98e+1. What is the difference between the Imports (in Local Currency Unit) of Ghana in 1978 and the Imports (in Local Currency Unit) of Guatemala in 1980?
Provide a succinct answer. -1.96e+09. What is the difference between the Imports (in Local Currency Unit) in Ghana in 1978 and the Imports (in Local Currency Unit) in Philippines in 1980?
Keep it short and to the point. -6.94e+1. What is the difference between the Imports (in Local Currency Unit) in Ghana in 1978 and the Imports (in Local Currency Unit) in Portugal in 1980?
Your response must be concise. -2.69e+09. What is the difference between the Imports (in Local Currency Unit) in Guatemala in 1978 and the Imports (in Local Currency Unit) in Philippines in 1980?
Your response must be concise. -6.77e+1. What is the difference between the Imports (in Local Currency Unit) in Guatemala in 1978 and the Imports (in Local Currency Unit) in Portugal in 1980?
Your answer should be compact. -1.04e+09. What is the difference between the Imports (in Local Currency Unit) in Philippines in 1978 and the Imports (in Local Currency Unit) in Portugal in 1980?
Make the answer very short. 3.90e+1. What is the difference between the Imports (in Local Currency Unit) of Ghana in 1979 and the Imports (in Local Currency Unit) of Guatemala in 1980?
Offer a terse response. -1.96e+09. What is the difference between the Imports (in Local Currency Unit) of Ghana in 1979 and the Imports (in Local Currency Unit) of Philippines in 1980?
Give a very brief answer. -6.94e+1. What is the difference between the Imports (in Local Currency Unit) of Ghana in 1979 and the Imports (in Local Currency Unit) of Portugal in 1980?
Offer a very short reply. -2.69e+09. What is the difference between the Imports (in Local Currency Unit) in Guatemala in 1979 and the Imports (in Local Currency Unit) in Philippines in 1980?
Provide a succinct answer. -6.76e+1. What is the difference between the Imports (in Local Currency Unit) of Guatemala in 1979 and the Imports (in Local Currency Unit) of Portugal in 1980?
Keep it short and to the point. -9.08e+08. What is the difference between the Imports (in Local Currency Unit) in Philippines in 1979 and the Imports (in Local Currency Unit) in Portugal in 1980?
Ensure brevity in your answer.  5.14e+1. What is the average Imports (in Local Currency Unit) of Ghana per year?
Your answer should be compact. 1.75e+05. What is the average Imports (in Local Currency Unit) of Guatemala per year?
Keep it short and to the point. 1.28e+09. What is the average Imports (in Local Currency Unit) of Philippines per year?
Your response must be concise. 3.76e+1. What is the average Imports (in Local Currency Unit) in Portugal per year?
Keep it short and to the point. 1.20e+09. In the year 1973, what is the difference between the Imports (in Local Currency Unit) of Ghana and Imports (in Local Currency Unit) of Guatemala?
Your answer should be very brief. -5.19e+08. In the year 1973, what is the difference between the Imports (in Local Currency Unit) of Ghana and Imports (in Local Currency Unit) of Philippines?
Give a very brief answer. -1.35e+1. In the year 1973, what is the difference between the Imports (in Local Currency Unit) of Ghana and Imports (in Local Currency Unit) of Portugal?
Your answer should be very brief. -4.85e+08. In the year 1973, what is the difference between the Imports (in Local Currency Unit) of Guatemala and Imports (in Local Currency Unit) of Philippines?
Make the answer very short. -1.30e+1. In the year 1973, what is the difference between the Imports (in Local Currency Unit) of Guatemala and Imports (in Local Currency Unit) of Portugal?
Provide a succinct answer. 3.38e+07. In the year 1973, what is the difference between the Imports (in Local Currency Unit) of Philippines and Imports (in Local Currency Unit) of Portugal?
Your answer should be compact. 1.31e+1. In the year 1974, what is the difference between the Imports (in Local Currency Unit) of Ghana and Imports (in Local Currency Unit) of Guatemala?
Your answer should be very brief. -8.11e+08. In the year 1974, what is the difference between the Imports (in Local Currency Unit) in Ghana and Imports (in Local Currency Unit) in Philippines?
Offer a terse response. -2.56e+1. In the year 1974, what is the difference between the Imports (in Local Currency Unit) in Ghana and Imports (in Local Currency Unit) in Portugal?
Make the answer very short. -7.30e+08. In the year 1974, what is the difference between the Imports (in Local Currency Unit) in Guatemala and Imports (in Local Currency Unit) in Philippines?
Offer a very short reply. -2.48e+1. In the year 1974, what is the difference between the Imports (in Local Currency Unit) of Guatemala and Imports (in Local Currency Unit) of Portugal?
Provide a succinct answer. 8.16e+07. In the year 1974, what is the difference between the Imports (in Local Currency Unit) in Philippines and Imports (in Local Currency Unit) in Portugal?
Your answer should be compact. 2.49e+1. In the year 1975, what is the difference between the Imports (in Local Currency Unit) in Ghana and Imports (in Local Currency Unit) in Guatemala?
Make the answer very short. -8.58e+08. In the year 1975, what is the difference between the Imports (in Local Currency Unit) in Ghana and Imports (in Local Currency Unit) in Philippines?
Keep it short and to the point. -2.93e+1. In the year 1975, what is the difference between the Imports (in Local Currency Unit) of Ghana and Imports (in Local Currency Unit) of Portugal?
Offer a very short reply. -6.30e+08. In the year 1975, what is the difference between the Imports (in Local Currency Unit) in Guatemala and Imports (in Local Currency Unit) in Philippines?
Your answer should be very brief. -2.84e+1. In the year 1975, what is the difference between the Imports (in Local Currency Unit) in Guatemala and Imports (in Local Currency Unit) in Portugal?
Your response must be concise. 2.28e+08. In the year 1975, what is the difference between the Imports (in Local Currency Unit) of Philippines and Imports (in Local Currency Unit) of Portugal?
Offer a terse response. 2.86e+1. In the year 1976, what is the difference between the Imports (in Local Currency Unit) of Ghana and Imports (in Local Currency Unit) of Guatemala?
Your answer should be very brief. -1.20e+09. In the year 1976, what is the difference between the Imports (in Local Currency Unit) of Ghana and Imports (in Local Currency Unit) of Philippines?
Give a very brief answer. -3.21e+1. In the year 1976, what is the difference between the Imports (in Local Currency Unit) in Ghana and Imports (in Local Currency Unit) in Portugal?
Offer a terse response. -7.37e+08. In the year 1976, what is the difference between the Imports (in Local Currency Unit) of Guatemala and Imports (in Local Currency Unit) of Philippines?
Your answer should be very brief. -3.09e+1. In the year 1976, what is the difference between the Imports (in Local Currency Unit) in Guatemala and Imports (in Local Currency Unit) in Portugal?
Provide a succinct answer. 4.67e+08. In the year 1976, what is the difference between the Imports (in Local Currency Unit) of Philippines and Imports (in Local Currency Unit) of Portugal?
Provide a short and direct response. 3.14e+1. In the year 1977, what is the difference between the Imports (in Local Currency Unit) in Ghana and Imports (in Local Currency Unit) in Guatemala?
Your answer should be compact. -1.44e+09. In the year 1977, what is the difference between the Imports (in Local Currency Unit) in Ghana and Imports (in Local Currency Unit) in Philippines?
Give a very brief answer. -3.51e+1. In the year 1977, what is the difference between the Imports (in Local Currency Unit) in Ghana and Imports (in Local Currency Unit) in Portugal?
Keep it short and to the point. -1.07e+09. In the year 1977, what is the difference between the Imports (in Local Currency Unit) of Guatemala and Imports (in Local Currency Unit) of Philippines?
Give a very brief answer. -3.37e+1. In the year 1977, what is the difference between the Imports (in Local Currency Unit) in Guatemala and Imports (in Local Currency Unit) in Portugal?
Your answer should be very brief. 3.71e+08. In the year 1977, what is the difference between the Imports (in Local Currency Unit) in Philippines and Imports (in Local Currency Unit) in Portugal?
Your answer should be compact. 3.40e+1. In the year 1978, what is the difference between the Imports (in Local Currency Unit) of Ghana and Imports (in Local Currency Unit) of Guatemala?
Make the answer very short. -1.65e+09. In the year 1978, what is the difference between the Imports (in Local Currency Unit) in Ghana and Imports (in Local Currency Unit) in Philippines?
Your answer should be compact. -4.17e+1. In the year 1978, what is the difference between the Imports (in Local Currency Unit) in Ghana and Imports (in Local Currency Unit) in Portugal?
Keep it short and to the point. -1.31e+09. In the year 1978, what is the difference between the Imports (in Local Currency Unit) in Guatemala and Imports (in Local Currency Unit) in Philippines?
Offer a very short reply. -4.01e+1. In the year 1978, what is the difference between the Imports (in Local Currency Unit) of Guatemala and Imports (in Local Currency Unit) of Portugal?
Make the answer very short. 3.49e+08. In the year 1978, what is the difference between the Imports (in Local Currency Unit) of Philippines and Imports (in Local Currency Unit) of Portugal?
Make the answer very short. 4.04e+1. In the year 1979, what is the difference between the Imports (in Local Currency Unit) in Ghana and Imports (in Local Currency Unit) in Guatemala?
Offer a terse response. -1.78e+09. In the year 1979, what is the difference between the Imports (in Local Currency Unit) of Ghana and Imports (in Local Currency Unit) of Philippines?
Offer a very short reply. -5.40e+1. In the year 1979, what is the difference between the Imports (in Local Currency Unit) in Ghana and Imports (in Local Currency Unit) in Portugal?
Keep it short and to the point. -1.92e+09. In the year 1979, what is the difference between the Imports (in Local Currency Unit) in Guatemala and Imports (in Local Currency Unit) in Philippines?
Offer a terse response. -5.23e+1. In the year 1979, what is the difference between the Imports (in Local Currency Unit) in Guatemala and Imports (in Local Currency Unit) in Portugal?
Ensure brevity in your answer.  -1.34e+08. In the year 1979, what is the difference between the Imports (in Local Currency Unit) of Philippines and Imports (in Local Currency Unit) of Portugal?
Provide a succinct answer. 5.21e+1. In the year 1980, what is the difference between the Imports (in Local Currency Unit) in Ghana and Imports (in Local Currency Unit) in Guatemala?
Ensure brevity in your answer.  -1.96e+09. In the year 1980, what is the difference between the Imports (in Local Currency Unit) of Ghana and Imports (in Local Currency Unit) of Philippines?
Make the answer very short. -6.94e+1. In the year 1980, what is the difference between the Imports (in Local Currency Unit) of Ghana and Imports (in Local Currency Unit) of Portugal?
Provide a short and direct response. -2.69e+09. In the year 1980, what is the difference between the Imports (in Local Currency Unit) of Guatemala and Imports (in Local Currency Unit) of Philippines?
Your answer should be very brief. -6.74e+1. In the year 1980, what is the difference between the Imports (in Local Currency Unit) of Guatemala and Imports (in Local Currency Unit) of Portugal?
Provide a short and direct response. -7.29e+08. In the year 1980, what is the difference between the Imports (in Local Currency Unit) in Philippines and Imports (in Local Currency Unit) in Portugal?
Provide a short and direct response. 6.67e+1. What is the ratio of the Imports (in Local Currency Unit) of Ghana in 1973 to that in 1974?
Give a very brief answer. 0.56. What is the ratio of the Imports (in Local Currency Unit) in Guatemala in 1973 to that in 1974?
Ensure brevity in your answer.  0.64. What is the ratio of the Imports (in Local Currency Unit) in Philippines in 1973 to that in 1974?
Keep it short and to the point. 0.53. What is the ratio of the Imports (in Local Currency Unit) in Portugal in 1973 to that in 1974?
Make the answer very short. 0.67. What is the ratio of the Imports (in Local Currency Unit) of Ghana in 1973 to that in 1975?
Give a very brief answer. 0.59. What is the ratio of the Imports (in Local Currency Unit) of Guatemala in 1973 to that in 1975?
Your answer should be compact. 0.6. What is the ratio of the Imports (in Local Currency Unit) in Philippines in 1973 to that in 1975?
Offer a terse response. 0.46. What is the ratio of the Imports (in Local Currency Unit) in Portugal in 1973 to that in 1975?
Provide a short and direct response. 0.77. What is the ratio of the Imports (in Local Currency Unit) of Ghana in 1973 to that in 1976?
Ensure brevity in your answer.  0.55. What is the ratio of the Imports (in Local Currency Unit) in Guatemala in 1973 to that in 1976?
Keep it short and to the point. 0.43. What is the ratio of the Imports (in Local Currency Unit) in Philippines in 1973 to that in 1976?
Your answer should be very brief. 0.42. What is the ratio of the Imports (in Local Currency Unit) in Portugal in 1973 to that in 1976?
Provide a short and direct response. 0.66. What is the ratio of the Imports (in Local Currency Unit) of Ghana in 1973 to that in 1977?
Provide a succinct answer. 0.45. What is the ratio of the Imports (in Local Currency Unit) of Guatemala in 1973 to that in 1977?
Provide a succinct answer. 0.36. What is the ratio of the Imports (in Local Currency Unit) of Philippines in 1973 to that in 1977?
Make the answer very short. 0.39. What is the ratio of the Imports (in Local Currency Unit) of Portugal in 1973 to that in 1977?
Your answer should be very brief. 0.45. What is the ratio of the Imports (in Local Currency Unit) of Ghana in 1973 to that in 1978?
Your response must be concise. 0.28. What is the ratio of the Imports (in Local Currency Unit) in Guatemala in 1973 to that in 1978?
Ensure brevity in your answer.  0.31. What is the ratio of the Imports (in Local Currency Unit) of Philippines in 1973 to that in 1978?
Provide a succinct answer. 0.32. What is the ratio of the Imports (in Local Currency Unit) in Portugal in 1973 to that in 1978?
Provide a short and direct response. 0.37. What is the ratio of the Imports (in Local Currency Unit) in Ghana in 1973 to that in 1979?
Provide a short and direct response. 0.18. What is the ratio of the Imports (in Local Currency Unit) of Guatemala in 1973 to that in 1979?
Offer a very short reply. 0.29. What is the ratio of the Imports (in Local Currency Unit) in Philippines in 1973 to that in 1979?
Make the answer very short. 0.25. What is the ratio of the Imports (in Local Currency Unit) in Portugal in 1973 to that in 1979?
Offer a terse response. 0.25. What is the ratio of the Imports (in Local Currency Unit) of Ghana in 1973 to that in 1980?
Your answer should be very brief. 0.15. What is the ratio of the Imports (in Local Currency Unit) of Guatemala in 1973 to that in 1980?
Your answer should be compact. 0.26. What is the ratio of the Imports (in Local Currency Unit) in Philippines in 1973 to that in 1980?
Keep it short and to the point. 0.2. What is the ratio of the Imports (in Local Currency Unit) of Portugal in 1973 to that in 1980?
Make the answer very short. 0.18. What is the ratio of the Imports (in Local Currency Unit) in Ghana in 1974 to that in 1975?
Your answer should be compact. 1.04. What is the ratio of the Imports (in Local Currency Unit) in Guatemala in 1974 to that in 1975?
Keep it short and to the point. 0.95. What is the ratio of the Imports (in Local Currency Unit) of Philippines in 1974 to that in 1975?
Provide a succinct answer. 0.87. What is the ratio of the Imports (in Local Currency Unit) of Portugal in 1974 to that in 1975?
Give a very brief answer. 1.16. What is the ratio of the Imports (in Local Currency Unit) of Ghana in 1974 to that in 1976?
Make the answer very short. 0.97. What is the ratio of the Imports (in Local Currency Unit) in Guatemala in 1974 to that in 1976?
Keep it short and to the point. 0.67. What is the ratio of the Imports (in Local Currency Unit) of Philippines in 1974 to that in 1976?
Offer a very short reply. 0.8. What is the ratio of the Imports (in Local Currency Unit) of Ghana in 1974 to that in 1977?
Provide a short and direct response. 0.79. What is the ratio of the Imports (in Local Currency Unit) in Guatemala in 1974 to that in 1977?
Provide a short and direct response. 0.56. What is the ratio of the Imports (in Local Currency Unit) in Philippines in 1974 to that in 1977?
Your answer should be very brief. 0.73. What is the ratio of the Imports (in Local Currency Unit) of Portugal in 1974 to that in 1977?
Offer a very short reply. 0.68. What is the ratio of the Imports (in Local Currency Unit) in Ghana in 1974 to that in 1978?
Provide a succinct answer. 0.5. What is the ratio of the Imports (in Local Currency Unit) in Guatemala in 1974 to that in 1978?
Offer a terse response. 0.49. What is the ratio of the Imports (in Local Currency Unit) in Philippines in 1974 to that in 1978?
Offer a very short reply. 0.61. What is the ratio of the Imports (in Local Currency Unit) in Portugal in 1974 to that in 1978?
Ensure brevity in your answer.  0.56. What is the ratio of the Imports (in Local Currency Unit) of Ghana in 1974 to that in 1979?
Ensure brevity in your answer.  0.32. What is the ratio of the Imports (in Local Currency Unit) of Guatemala in 1974 to that in 1979?
Your response must be concise. 0.45. What is the ratio of the Imports (in Local Currency Unit) of Philippines in 1974 to that in 1979?
Ensure brevity in your answer.  0.47. What is the ratio of the Imports (in Local Currency Unit) in Portugal in 1974 to that in 1979?
Provide a short and direct response. 0.38. What is the ratio of the Imports (in Local Currency Unit) in Ghana in 1974 to that in 1980?
Give a very brief answer. 0.26. What is the ratio of the Imports (in Local Currency Unit) of Guatemala in 1974 to that in 1980?
Offer a very short reply. 0.41. What is the ratio of the Imports (in Local Currency Unit) in Philippines in 1974 to that in 1980?
Provide a short and direct response. 0.37. What is the ratio of the Imports (in Local Currency Unit) of Portugal in 1974 to that in 1980?
Make the answer very short. 0.27. What is the ratio of the Imports (in Local Currency Unit) in Ghana in 1975 to that in 1976?
Provide a short and direct response. 0.93. What is the ratio of the Imports (in Local Currency Unit) in Guatemala in 1975 to that in 1976?
Give a very brief answer. 0.71. What is the ratio of the Imports (in Local Currency Unit) of Philippines in 1975 to that in 1976?
Your answer should be very brief. 0.91. What is the ratio of the Imports (in Local Currency Unit) in Portugal in 1975 to that in 1976?
Provide a succinct answer. 0.85. What is the ratio of the Imports (in Local Currency Unit) in Ghana in 1975 to that in 1977?
Offer a very short reply. 0.76. What is the ratio of the Imports (in Local Currency Unit) of Guatemala in 1975 to that in 1977?
Keep it short and to the point. 0.6. What is the ratio of the Imports (in Local Currency Unit) in Philippines in 1975 to that in 1977?
Offer a terse response. 0.83. What is the ratio of the Imports (in Local Currency Unit) of Portugal in 1975 to that in 1977?
Give a very brief answer. 0.59. What is the ratio of the Imports (in Local Currency Unit) of Ghana in 1975 to that in 1978?
Your answer should be very brief. 0.48. What is the ratio of the Imports (in Local Currency Unit) in Guatemala in 1975 to that in 1978?
Give a very brief answer. 0.52. What is the ratio of the Imports (in Local Currency Unit) of Philippines in 1975 to that in 1978?
Provide a succinct answer. 0.7. What is the ratio of the Imports (in Local Currency Unit) in Portugal in 1975 to that in 1978?
Ensure brevity in your answer.  0.48. What is the ratio of the Imports (in Local Currency Unit) of Ghana in 1975 to that in 1979?
Provide a succinct answer. 0.31. What is the ratio of the Imports (in Local Currency Unit) of Guatemala in 1975 to that in 1979?
Ensure brevity in your answer.  0.48. What is the ratio of the Imports (in Local Currency Unit) in Philippines in 1975 to that in 1979?
Keep it short and to the point. 0.54. What is the ratio of the Imports (in Local Currency Unit) of Portugal in 1975 to that in 1979?
Provide a succinct answer. 0.33. What is the ratio of the Imports (in Local Currency Unit) of Ghana in 1975 to that in 1980?
Keep it short and to the point. 0.25. What is the ratio of the Imports (in Local Currency Unit) in Guatemala in 1975 to that in 1980?
Your answer should be compact. 0.44. What is the ratio of the Imports (in Local Currency Unit) of Philippines in 1975 to that in 1980?
Your answer should be very brief. 0.42. What is the ratio of the Imports (in Local Currency Unit) of Portugal in 1975 to that in 1980?
Offer a very short reply. 0.23. What is the ratio of the Imports (in Local Currency Unit) of Ghana in 1976 to that in 1977?
Ensure brevity in your answer.  0.81. What is the ratio of the Imports (in Local Currency Unit) in Guatemala in 1976 to that in 1977?
Give a very brief answer. 0.84. What is the ratio of the Imports (in Local Currency Unit) of Philippines in 1976 to that in 1977?
Make the answer very short. 0.92. What is the ratio of the Imports (in Local Currency Unit) of Portugal in 1976 to that in 1977?
Provide a succinct answer. 0.69. What is the ratio of the Imports (in Local Currency Unit) of Ghana in 1976 to that in 1978?
Provide a short and direct response. 0.52. What is the ratio of the Imports (in Local Currency Unit) in Guatemala in 1976 to that in 1978?
Give a very brief answer. 0.73. What is the ratio of the Imports (in Local Currency Unit) of Philippines in 1976 to that in 1978?
Provide a succinct answer. 0.77. What is the ratio of the Imports (in Local Currency Unit) of Portugal in 1976 to that in 1978?
Your answer should be very brief. 0.56. What is the ratio of the Imports (in Local Currency Unit) of Ghana in 1976 to that in 1979?
Make the answer very short. 0.33. What is the ratio of the Imports (in Local Currency Unit) of Guatemala in 1976 to that in 1979?
Make the answer very short. 0.67. What is the ratio of the Imports (in Local Currency Unit) of Philippines in 1976 to that in 1979?
Offer a terse response. 0.59. What is the ratio of the Imports (in Local Currency Unit) of Portugal in 1976 to that in 1979?
Offer a very short reply. 0.38. What is the ratio of the Imports (in Local Currency Unit) in Ghana in 1976 to that in 1980?
Your response must be concise. 0.27. What is the ratio of the Imports (in Local Currency Unit) of Guatemala in 1976 to that in 1980?
Offer a terse response. 0.61. What is the ratio of the Imports (in Local Currency Unit) of Philippines in 1976 to that in 1980?
Offer a very short reply. 0.46. What is the ratio of the Imports (in Local Currency Unit) in Portugal in 1976 to that in 1980?
Your answer should be very brief. 0.27. What is the ratio of the Imports (in Local Currency Unit) of Ghana in 1977 to that in 1978?
Your answer should be compact. 0.63. What is the ratio of the Imports (in Local Currency Unit) in Guatemala in 1977 to that in 1978?
Your answer should be compact. 0.87. What is the ratio of the Imports (in Local Currency Unit) of Philippines in 1977 to that in 1978?
Your answer should be very brief. 0.84. What is the ratio of the Imports (in Local Currency Unit) of Portugal in 1977 to that in 1978?
Offer a terse response. 0.82. What is the ratio of the Imports (in Local Currency Unit) in Ghana in 1977 to that in 1979?
Give a very brief answer. 0.41. What is the ratio of the Imports (in Local Currency Unit) in Guatemala in 1977 to that in 1979?
Your response must be concise. 0.81. What is the ratio of the Imports (in Local Currency Unit) in Philippines in 1977 to that in 1979?
Make the answer very short. 0.65. What is the ratio of the Imports (in Local Currency Unit) in Portugal in 1977 to that in 1979?
Offer a terse response. 0.56. What is the ratio of the Imports (in Local Currency Unit) in Ghana in 1977 to that in 1980?
Provide a short and direct response. 0.33. What is the ratio of the Imports (in Local Currency Unit) in Guatemala in 1977 to that in 1980?
Ensure brevity in your answer.  0.73. What is the ratio of the Imports (in Local Currency Unit) in Philippines in 1977 to that in 1980?
Your answer should be very brief. 0.51. What is the ratio of the Imports (in Local Currency Unit) in Portugal in 1977 to that in 1980?
Offer a terse response. 0.4. What is the ratio of the Imports (in Local Currency Unit) of Ghana in 1978 to that in 1979?
Offer a very short reply. 0.65. What is the ratio of the Imports (in Local Currency Unit) in Guatemala in 1978 to that in 1979?
Offer a terse response. 0.93. What is the ratio of the Imports (in Local Currency Unit) of Philippines in 1978 to that in 1979?
Ensure brevity in your answer.  0.77. What is the ratio of the Imports (in Local Currency Unit) of Portugal in 1978 to that in 1979?
Offer a very short reply. 0.68. What is the ratio of the Imports (in Local Currency Unit) of Ghana in 1978 to that in 1980?
Your response must be concise. 0.52. What is the ratio of the Imports (in Local Currency Unit) in Guatemala in 1978 to that in 1980?
Your response must be concise. 0.84. What is the ratio of the Imports (in Local Currency Unit) of Philippines in 1978 to that in 1980?
Ensure brevity in your answer.  0.6. What is the ratio of the Imports (in Local Currency Unit) of Portugal in 1978 to that in 1980?
Ensure brevity in your answer.  0.49. What is the ratio of the Imports (in Local Currency Unit) in Ghana in 1979 to that in 1980?
Your answer should be compact. 0.8. What is the ratio of the Imports (in Local Currency Unit) in Guatemala in 1979 to that in 1980?
Your answer should be compact. 0.91. What is the ratio of the Imports (in Local Currency Unit) in Philippines in 1979 to that in 1980?
Your response must be concise. 0.78. What is the ratio of the Imports (in Local Currency Unit) of Portugal in 1979 to that in 1980?
Your answer should be very brief. 0.71. What is the difference between the highest and the second highest Imports (in Local Currency Unit) in Ghana?
Provide a succinct answer. 7.73e+04. What is the difference between the highest and the second highest Imports (in Local Currency Unit) of Guatemala?
Offer a very short reply. 1.79e+08. What is the difference between the highest and the second highest Imports (in Local Currency Unit) of Philippines?
Your answer should be very brief. 1.54e+1. What is the difference between the highest and the second highest Imports (in Local Currency Unit) in Portugal?
Provide a succinct answer. 7.74e+08. What is the difference between the highest and the lowest Imports (in Local Currency Unit) of Ghana?
Offer a terse response. 3.35e+05. What is the difference between the highest and the lowest Imports (in Local Currency Unit) in Guatemala?
Your response must be concise. 1.44e+09. What is the difference between the highest and the lowest Imports (in Local Currency Unit) of Philippines?
Make the answer very short. 5.58e+1. What is the difference between the highest and the lowest Imports (in Local Currency Unit) of Portugal?
Provide a succinct answer. 2.21e+09. 